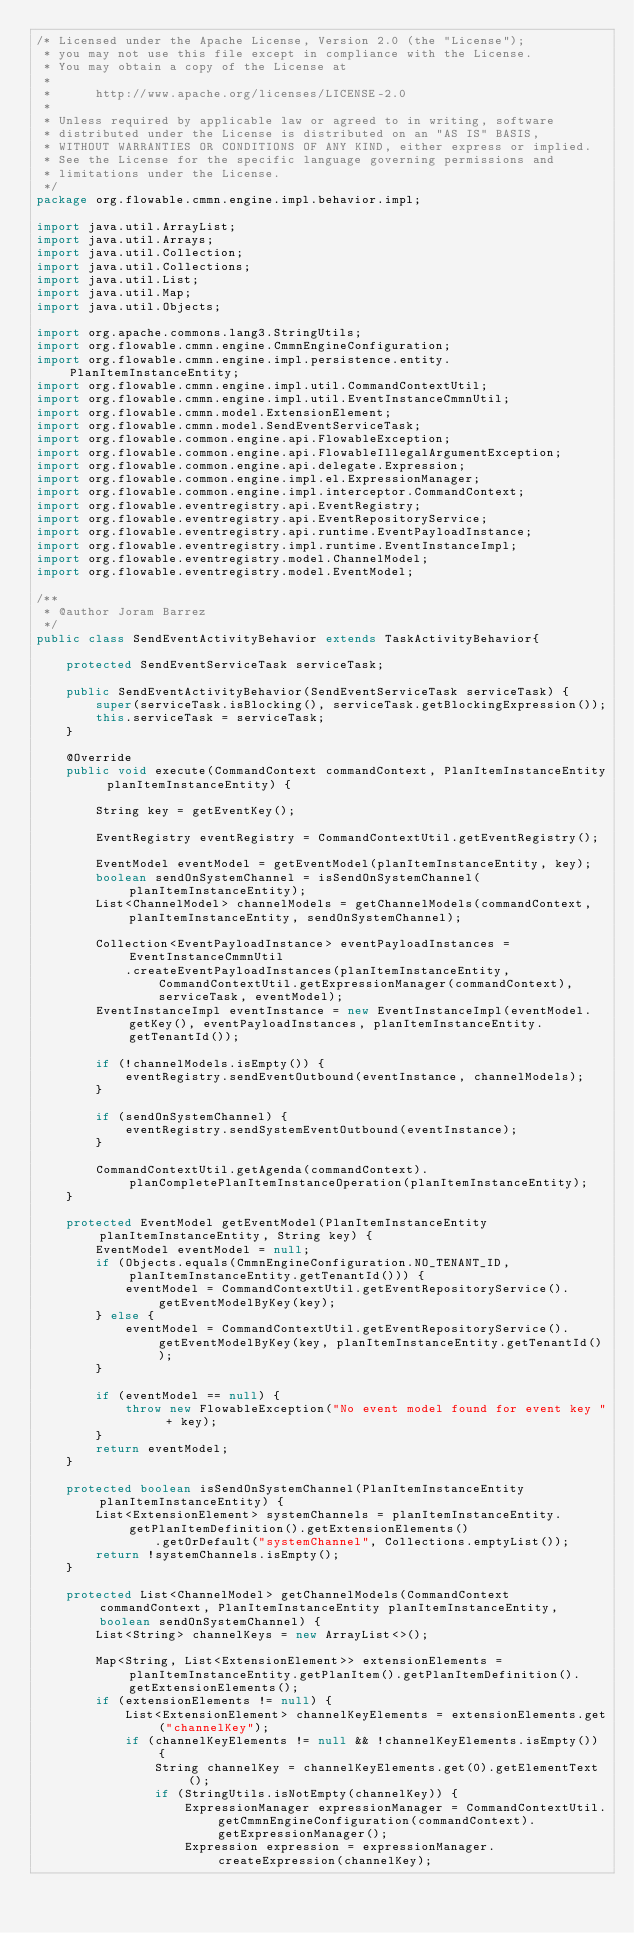Convert code to text. <code><loc_0><loc_0><loc_500><loc_500><_Java_>/* Licensed under the Apache License, Version 2.0 (the "License");
 * you may not use this file except in compliance with the License.
 * You may obtain a copy of the License at
 *
 *      http://www.apache.org/licenses/LICENSE-2.0
 *
 * Unless required by applicable law or agreed to in writing, software
 * distributed under the License is distributed on an "AS IS" BASIS,
 * WITHOUT WARRANTIES OR CONDITIONS OF ANY KIND, either express or implied.
 * See the License for the specific language governing permissions and
 * limitations under the License.
 */
package org.flowable.cmmn.engine.impl.behavior.impl;

import java.util.ArrayList;
import java.util.Arrays;
import java.util.Collection;
import java.util.Collections;
import java.util.List;
import java.util.Map;
import java.util.Objects;

import org.apache.commons.lang3.StringUtils;
import org.flowable.cmmn.engine.CmmnEngineConfiguration;
import org.flowable.cmmn.engine.impl.persistence.entity.PlanItemInstanceEntity;
import org.flowable.cmmn.engine.impl.util.CommandContextUtil;
import org.flowable.cmmn.engine.impl.util.EventInstanceCmmnUtil;
import org.flowable.cmmn.model.ExtensionElement;
import org.flowable.cmmn.model.SendEventServiceTask;
import org.flowable.common.engine.api.FlowableException;
import org.flowable.common.engine.api.FlowableIllegalArgumentException;
import org.flowable.common.engine.api.delegate.Expression;
import org.flowable.common.engine.impl.el.ExpressionManager;
import org.flowable.common.engine.impl.interceptor.CommandContext;
import org.flowable.eventregistry.api.EventRegistry;
import org.flowable.eventregistry.api.EventRepositoryService;
import org.flowable.eventregistry.api.runtime.EventPayloadInstance;
import org.flowable.eventregistry.impl.runtime.EventInstanceImpl;
import org.flowable.eventregistry.model.ChannelModel;
import org.flowable.eventregistry.model.EventModel;

/**
 * @author Joram Barrez
 */
public class SendEventActivityBehavior extends TaskActivityBehavior{

    protected SendEventServiceTask serviceTask;

    public SendEventActivityBehavior(SendEventServiceTask serviceTask) {
        super(serviceTask.isBlocking(), serviceTask.getBlockingExpression());
        this.serviceTask = serviceTask;
    }

    @Override
    public void execute(CommandContext commandContext, PlanItemInstanceEntity planItemInstanceEntity) {

        String key = getEventKey();

        EventRegistry eventRegistry = CommandContextUtil.getEventRegistry();

        EventModel eventModel = getEventModel(planItemInstanceEntity, key);
        boolean sendOnSystemChannel = isSendOnSystemChannel(planItemInstanceEntity);
        List<ChannelModel> channelModels = getChannelModels(commandContext, planItemInstanceEntity, sendOnSystemChannel);

        Collection<EventPayloadInstance> eventPayloadInstances = EventInstanceCmmnUtil
            .createEventPayloadInstances(planItemInstanceEntity, CommandContextUtil.getExpressionManager(commandContext), serviceTask, eventModel);
        EventInstanceImpl eventInstance = new EventInstanceImpl(eventModel.getKey(), eventPayloadInstances, planItemInstanceEntity.getTenantId());

        if (!channelModels.isEmpty()) {
            eventRegistry.sendEventOutbound(eventInstance, channelModels);
        }

        if (sendOnSystemChannel) {
            eventRegistry.sendSystemEventOutbound(eventInstance);
        }

        CommandContextUtil.getAgenda(commandContext).planCompletePlanItemInstanceOperation(planItemInstanceEntity);
    }

    protected EventModel getEventModel(PlanItemInstanceEntity planItemInstanceEntity, String key) {
        EventModel eventModel = null;
        if (Objects.equals(CmmnEngineConfiguration.NO_TENANT_ID, planItemInstanceEntity.getTenantId())) {
            eventModel = CommandContextUtil.getEventRepositoryService().getEventModelByKey(key);
        } else {
            eventModel = CommandContextUtil.getEventRepositoryService().getEventModelByKey(key, planItemInstanceEntity.getTenantId());
        }

        if (eventModel == null) {
            throw new FlowableException("No event model found for event key " + key);
        }
        return eventModel;
    }

    protected boolean isSendOnSystemChannel(PlanItemInstanceEntity planItemInstanceEntity) {
        List<ExtensionElement> systemChannels = planItemInstanceEntity.getPlanItemDefinition().getExtensionElements()
                .getOrDefault("systemChannel", Collections.emptyList());
        return !systemChannels.isEmpty();
    }

    protected List<ChannelModel> getChannelModels(CommandContext commandContext, PlanItemInstanceEntity planItemInstanceEntity, boolean sendOnSystemChannel) {
        List<String> channelKeys = new ArrayList<>();

        Map<String, List<ExtensionElement>> extensionElements = planItemInstanceEntity.getPlanItem().getPlanItemDefinition().getExtensionElements();
        if (extensionElements != null) {
            List<ExtensionElement> channelKeyElements = extensionElements.get("channelKey");
            if (channelKeyElements != null && !channelKeyElements.isEmpty()) {
                String channelKey = channelKeyElements.get(0).getElementText();
                if (StringUtils.isNotEmpty(channelKey)) {
                    ExpressionManager expressionManager = CommandContextUtil.getCmmnEngineConfiguration(commandContext).getExpressionManager();
                    Expression expression = expressionManager.createExpression(channelKey);</code> 